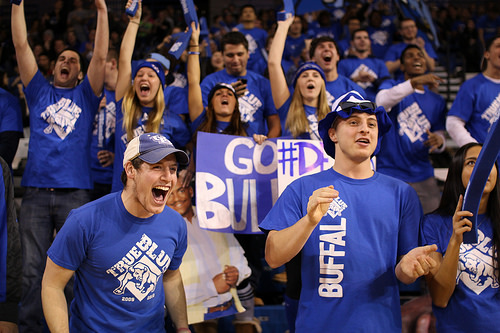<image>
Is there a man on the girl? No. The man is not positioned on the girl. They may be near each other, but the man is not supported by or resting on top of the girl. Is the hat on the man? No. The hat is not positioned on the man. They may be near each other, but the hat is not supported by or resting on top of the man. Is there a sign in front of the sports fan? No. The sign is not in front of the sports fan. The spatial positioning shows a different relationship between these objects. 